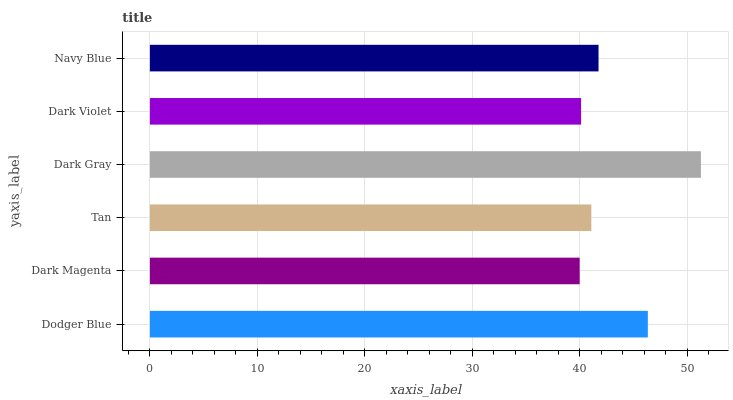Is Dark Magenta the minimum?
Answer yes or no. Yes. Is Dark Gray the maximum?
Answer yes or no. Yes. Is Tan the minimum?
Answer yes or no. No. Is Tan the maximum?
Answer yes or no. No. Is Tan greater than Dark Magenta?
Answer yes or no. Yes. Is Dark Magenta less than Tan?
Answer yes or no. Yes. Is Dark Magenta greater than Tan?
Answer yes or no. No. Is Tan less than Dark Magenta?
Answer yes or no. No. Is Navy Blue the high median?
Answer yes or no. Yes. Is Tan the low median?
Answer yes or no. Yes. Is Dark Magenta the high median?
Answer yes or no. No. Is Dark Violet the low median?
Answer yes or no. No. 